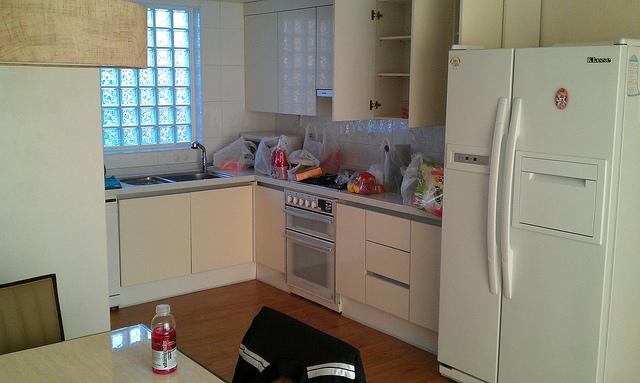What can you do in this room?
Answer briefly. Cook. What color is the counter?
Keep it brief. White. Is the floor tiled?
Concise answer only. No. What is on the table?
Be succinct. Vitamin water. How many magnets are on the refrigerator?
Give a very brief answer. 1. What is sitting on top of the cabinet?
Short answer required. Food. How many cabinet doors are open in this picture?
Answer briefly. 3. What color beverage is in the bottle on the table?
Quick response, please. Red. 